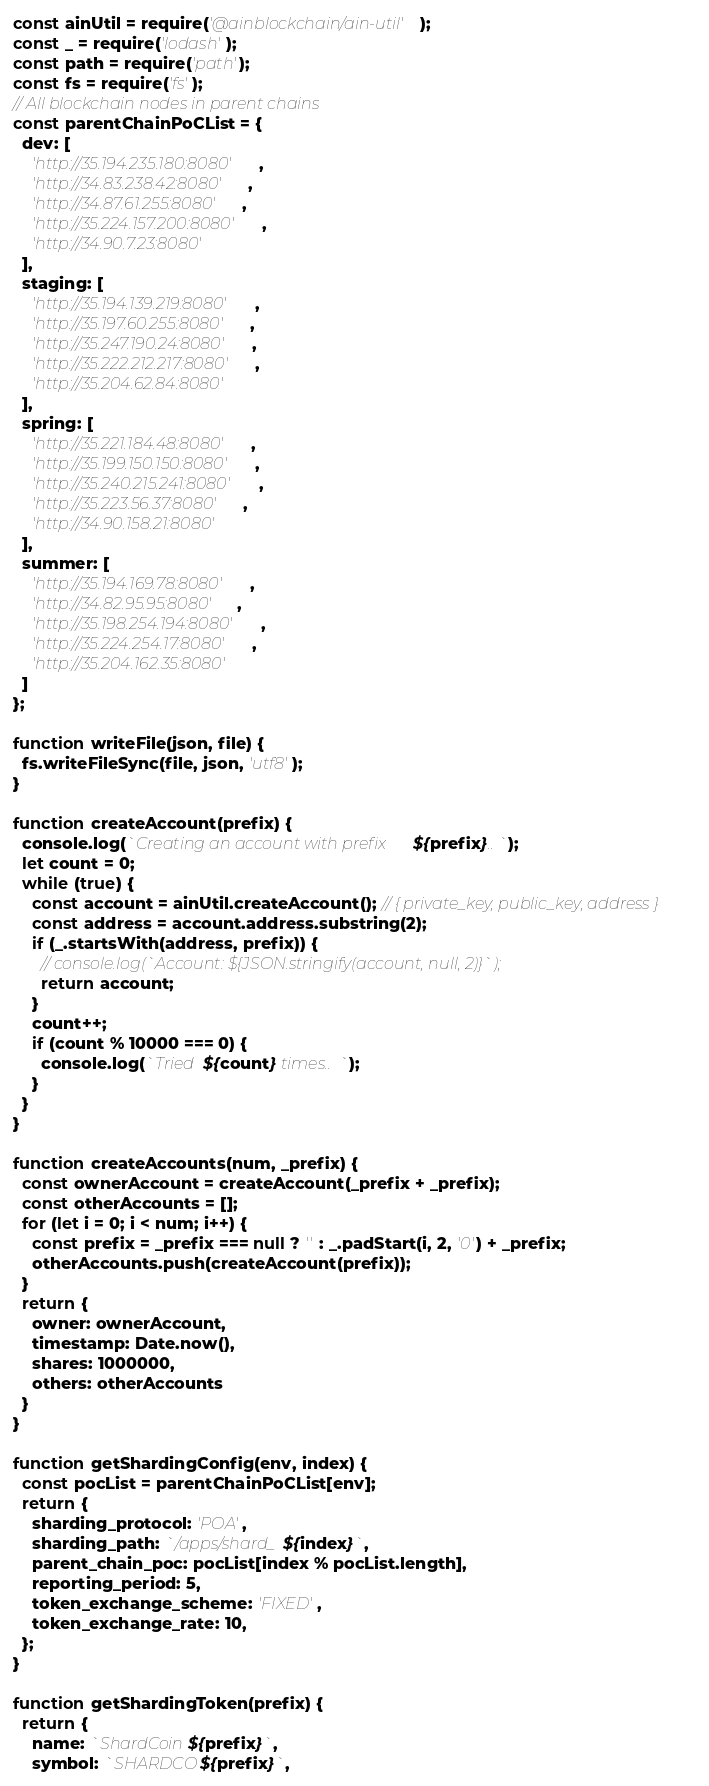<code> <loc_0><loc_0><loc_500><loc_500><_JavaScript_>const ainUtil = require('@ainblockchain/ain-util');
const _ = require('lodash');
const path = require('path');
const fs = require('fs');
// All blockchain nodes in parent chains
const parentChainPoCList = {
  dev: [
    'http://35.194.235.180:8080',
    'http://34.83.238.42:8080',
    'http://34.87.61.255:8080',
    'http://35.224.157.200:8080',
    'http://34.90.7.23:8080'
  ],
  staging: [
    'http://35.194.139.219:8080',
    'http://35.197.60.255:8080',
    'http://35.247.190.24:8080',
    'http://35.222.212.217:8080',
    'http://35.204.62.84:8080'
  ],
  spring: [
    'http://35.221.184.48:8080',
    'http://35.199.150.150:8080',
    'http://35.240.215.241:8080',
    'http://35.223.56.37:8080',
    'http://34.90.158.21:8080'
  ],
  summer: [
    'http://35.194.169.78:8080',
    'http://34.82.95.95:8080',
    'http://35.198.254.194:8080',
    'http://35.224.254.17:8080',
    'http://35.204.162.35:8080'
  ]
};

function writeFile(json, file) {
  fs.writeFileSync(file, json, 'utf8');
}

function createAccount(prefix) {
  console.log(`Creating an account with prefix ${prefix}..`);
  let count = 0;
  while (true) {
    const account = ainUtil.createAccount(); // { private_key, public_key, address }
    const address = account.address.substring(2);
    if (_.startsWith(address, prefix)) {
      // console.log(`Account: ${JSON.stringify(account, null, 2)}`);
      return account;
    }
    count++;
    if (count % 10000 === 0) {
      console.log(`Tried ${count} times..`);
    }
  }
}

function createAccounts(num, _prefix) {
  const ownerAccount = createAccount(_prefix + _prefix);
  const otherAccounts = [];
  for (let i = 0; i < num; i++) {
    const prefix = _prefix === null ? '' : _.padStart(i, 2, '0') + _prefix;
    otherAccounts.push(createAccount(prefix));
  }
  return {
    owner: ownerAccount,
    timestamp: Date.now(),
    shares: 1000000,
    others: otherAccounts
  }
}

function getShardingConfig(env, index) {
  const pocList = parentChainPoCList[env];
  return {
    sharding_protocol: 'POA',
    sharding_path: `/apps/shard_${index}`,
    parent_chain_poc: pocList[index % pocList.length],
    reporting_period: 5,
    token_exchange_scheme: 'FIXED',
    token_exchange_rate: 10,
  };
}

function getShardingToken(prefix) {
  return {
    name: `ShardCoin${prefix}`,
    symbol: `SHARDCO${prefix}`,</code> 